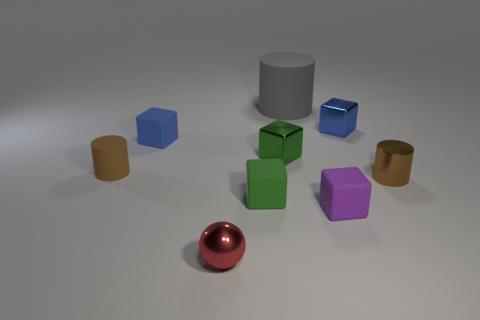What material is the small object that is the same color as the tiny rubber cylinder?
Offer a terse response. Metal. There is a object that is in front of the small green matte block and behind the red ball; how big is it?
Offer a terse response. Small. Does the blue object to the right of the big gray matte thing have the same shape as the brown object to the right of the small purple thing?
Ensure brevity in your answer.  No. There is a object that is the same color as the tiny matte cylinder; what is its shape?
Your answer should be compact. Cylinder. How many green things have the same material as the ball?
Provide a succinct answer. 1. What is the shape of the small rubber object that is right of the tiny blue rubber object and left of the gray object?
Offer a very short reply. Cube. Are the small blue object in front of the blue shiny object and the red thing made of the same material?
Give a very brief answer. No. Is there anything else that has the same material as the red sphere?
Provide a succinct answer. Yes. There is a cylinder that is the same size as the brown metal object; what color is it?
Offer a very short reply. Brown. Are there any rubber balls of the same color as the small shiny cylinder?
Your response must be concise. No. 